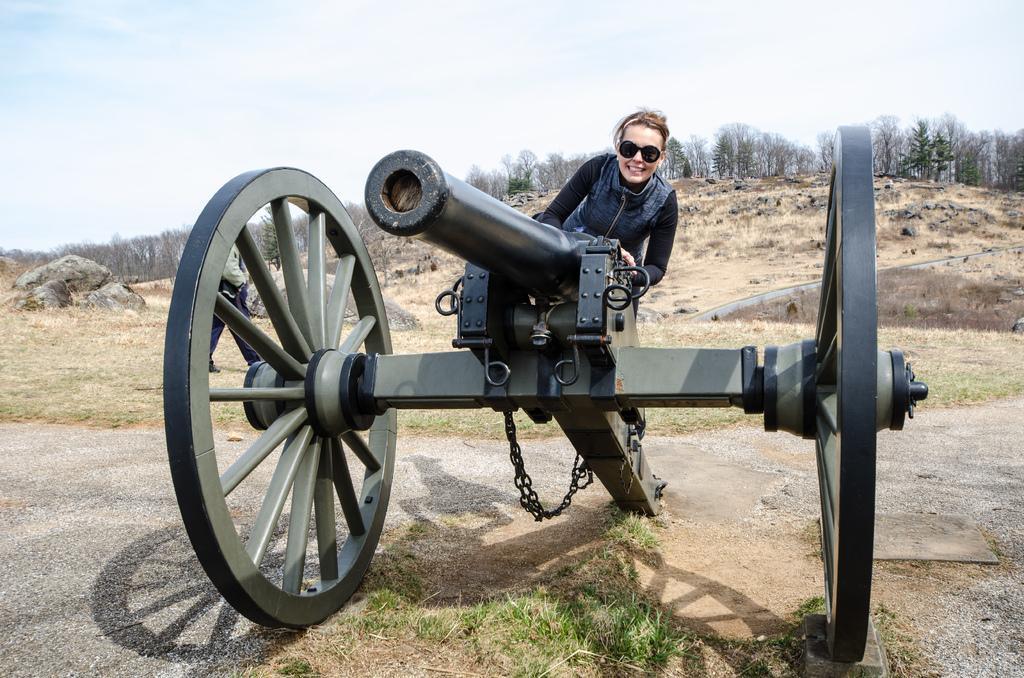Can you describe this image briefly? In this image I can see canon, back I can see the person wearing black jacket. I can also see few trees in green color, sky in white and blue color. 